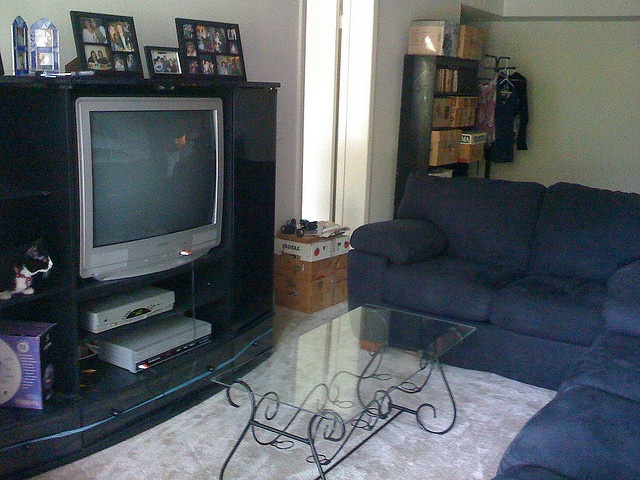Describe the objects in this image and their specific colors. I can see couch in darkgray, black, navy, darkblue, and gray tones, tv in darkgray, gray, purple, and black tones, couch in darkgray, navy, darkblue, and gray tones, cat in darkgray, black, and gray tones, and book in darkgray, gray, darkgreen, and black tones in this image. 